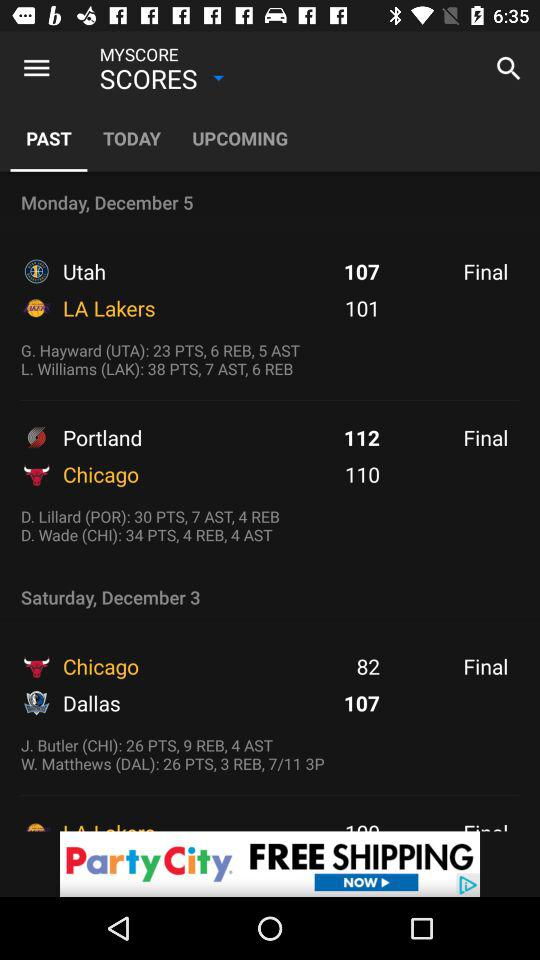How many points did the Lakers score in their last game?
Answer the question using a single word or phrase. 101 